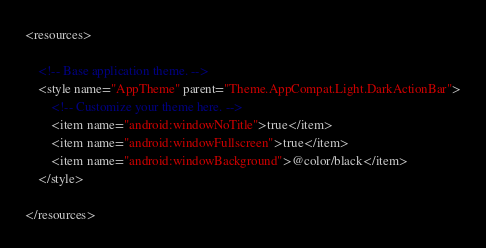<code> <loc_0><loc_0><loc_500><loc_500><_XML_><resources>

    <!-- Base application theme. -->
    <style name="AppTheme" parent="Theme.AppCompat.Light.DarkActionBar">
        <!-- Customize your theme here. -->
        <item name="android:windowNoTitle">true</item>
        <item name="android:windowFullscreen">true</item>
        <item name="android:windowBackground">@color/black</item>
    </style>

</resources>
</code> 